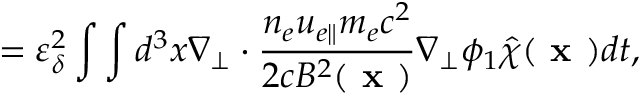Convert formula to latex. <formula><loc_0><loc_0><loc_500><loc_500>= \varepsilon _ { \delta } ^ { 2 } \int \int d ^ { 3 } x \nabla _ { \perp } \cdot \frac { n _ { e } u _ { e \| } m _ { e } c ^ { 2 } } { 2 c B ^ { 2 } ( x ) } \nabla _ { \perp } \phi _ { 1 } \hat { \chi } ( x ) d t ,</formula> 